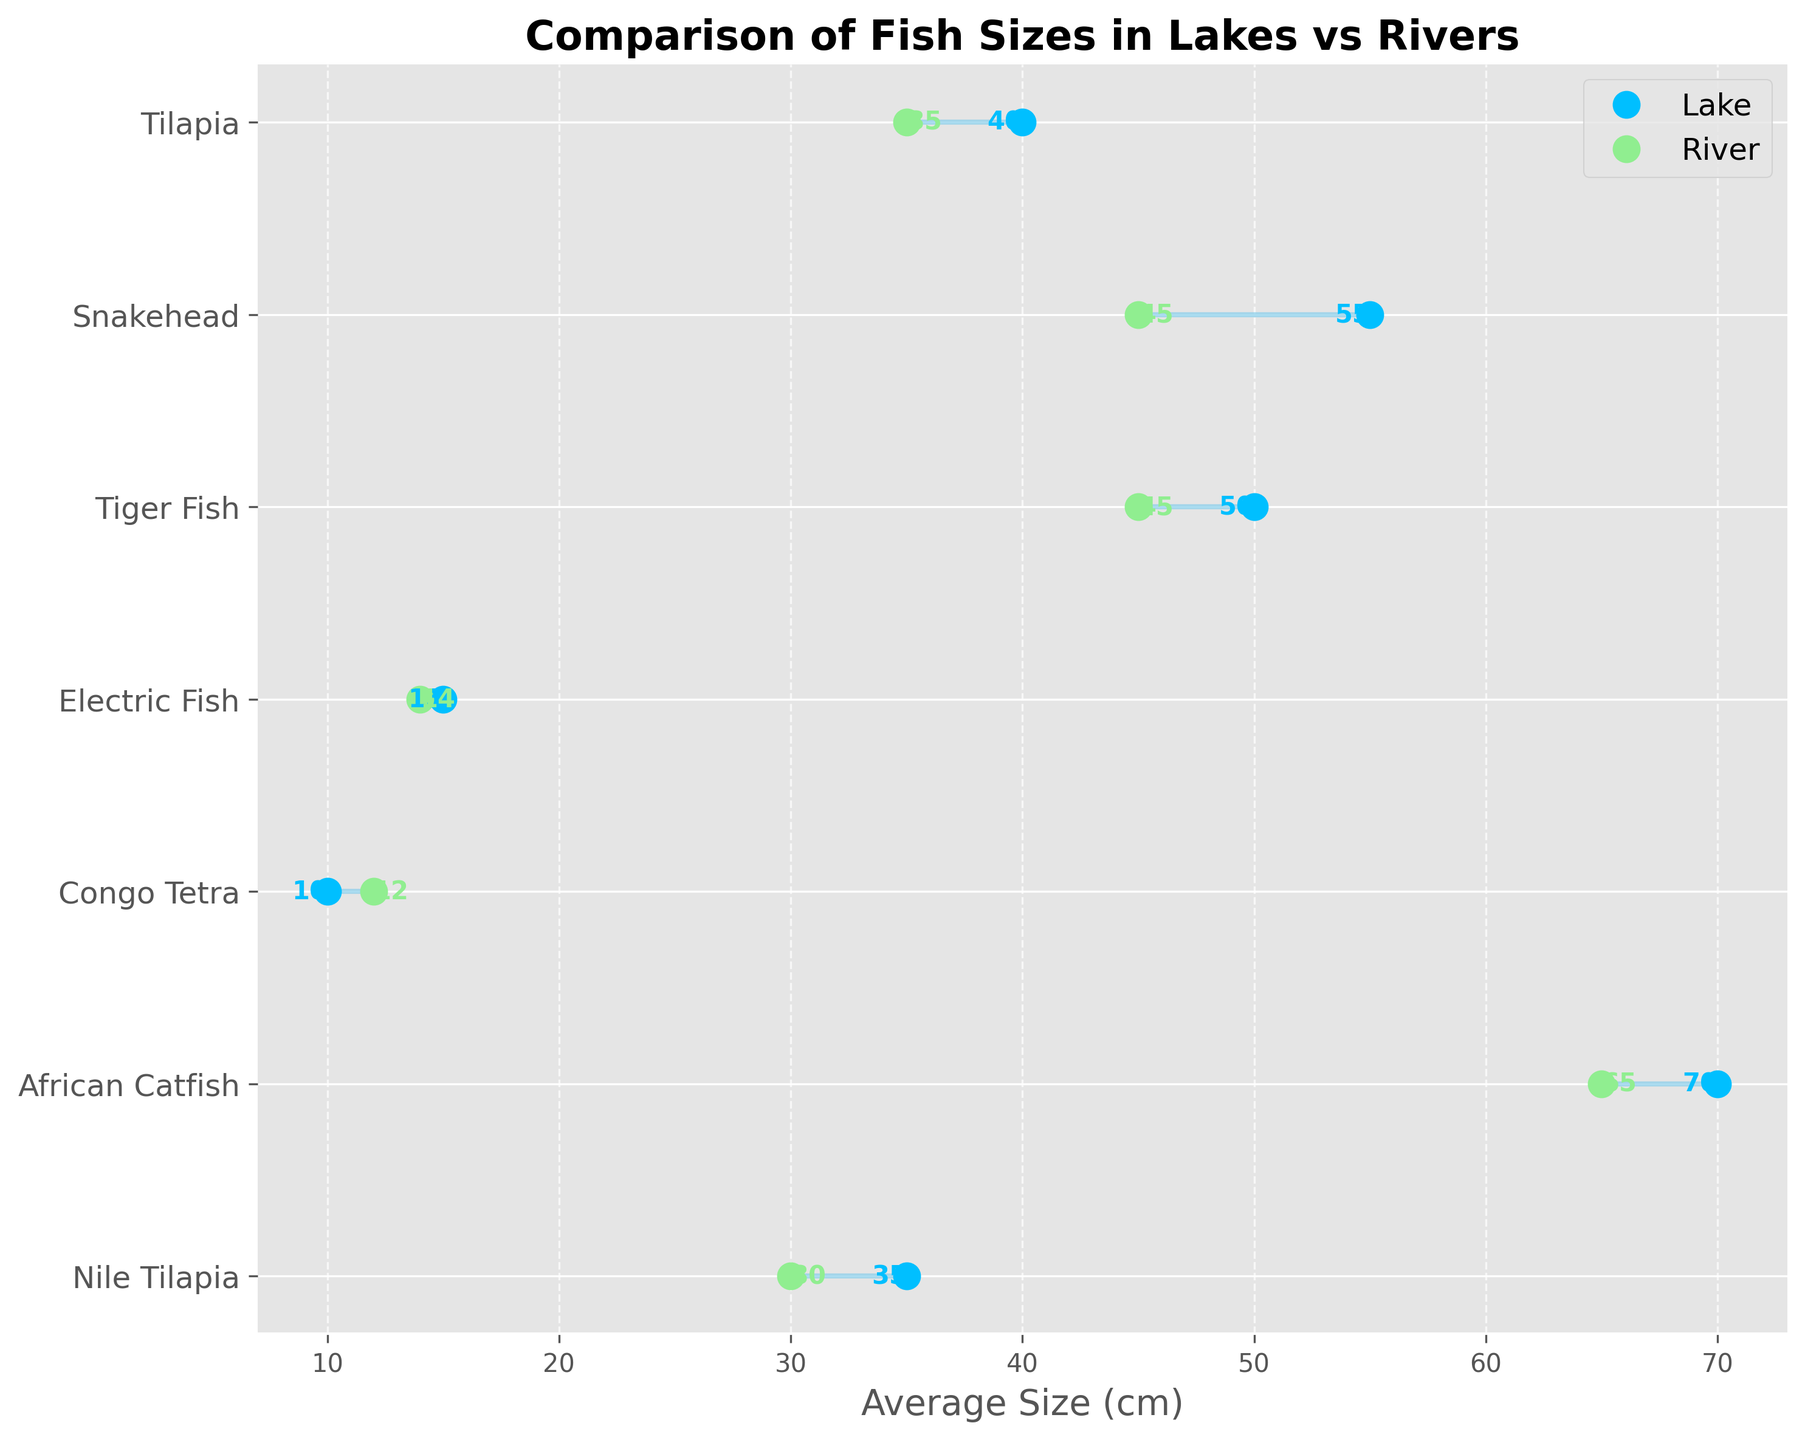What's the title of the plot? The title is located at the top of the plot. It usually summarizes what the plot represents.
Answer: Comparison of Fish Sizes in Lakes vs Rivers What is the average size of African Catfish in Lake Kivu? To find this, look for the "African Catfish" on the y-axis, then check the blue dot labeled as "Lake" on the corresponding horizontal line.
Answer: 70 cm Is the average size of Electric Fish larger in Lake Kivu or Congo River? Compare the positions of the blue and green dots on the "Electric Fish" line. The blue dot represents Lake, and the green dot represents River. The blue dot (Lake Kivu) is slightly farther to the right.
Answer: Lake Kivu Which fish species shows the largest difference in average size between lakes and rivers? Observe the length of the horizontal lines. The longest line represents the largest size difference.
Answer: Snakehead What color represents fish sizes in rivers? Check the color of the dots labeled as "River" in the legend.
Answer: Light green For which fish is the size in rivers greater than in lakes? Compare the green and blue dots for each line. Find the line where the green dot is further to the right than the blue dot.
Answer: Congo Tetra What’s the average size of Nile Tilapia in the Congo River? Locate "Nile Tilapia" on the y-axis, then find the value of the green dot along the same horizontal line.
Answer: 30 cm Which fish species has the lowest average size in lakes? Look for the species with the blue dot closest to the left side of the plot.
Answer: Congo Tetra Calculate the difference in size of the Tiger Fish between Lake Tanganyika and the Congo River. On the "Tiger Fish" line, subtract the value of the green dot from the blue dot. 50 (Lake) - 45 (River) = 5 cm.
Answer: 5 cm What’s the median average size of fish in rivers? Arrange the river sizes (30, 65, 12, 14, 45, 45, 35) in ascending order: (12, 14, 30, 35, 45, 45, 65). The median is the middle value.
Answer: 35 cm 